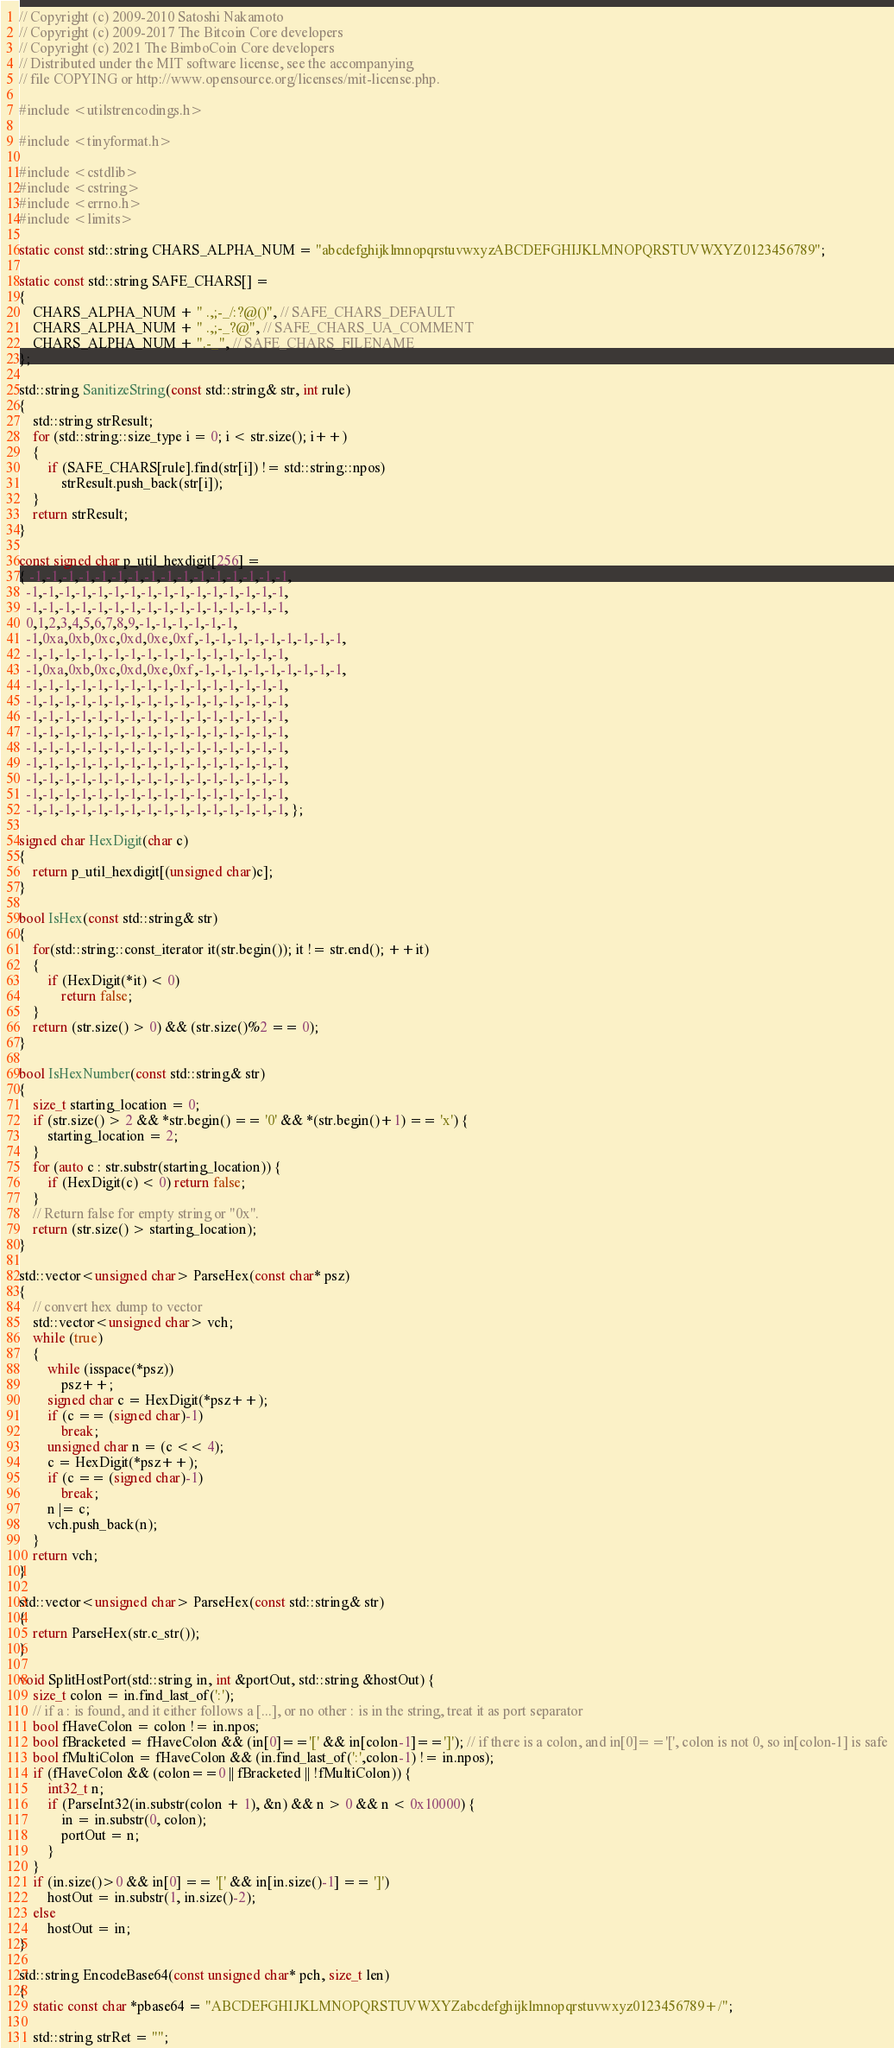Convert code to text. <code><loc_0><loc_0><loc_500><loc_500><_C++_>// Copyright (c) 2009-2010 Satoshi Nakamoto
// Copyright (c) 2009-2017 The Bitcoin Core developers
// Copyright (c) 2021 The BimboCoin Core developers
// Distributed under the MIT software license, see the accompanying
// file COPYING or http://www.opensource.org/licenses/mit-license.php.

#include <utilstrencodings.h>

#include <tinyformat.h>

#include <cstdlib>
#include <cstring>
#include <errno.h>
#include <limits>

static const std::string CHARS_ALPHA_NUM = "abcdefghijklmnopqrstuvwxyzABCDEFGHIJKLMNOPQRSTUVWXYZ0123456789";

static const std::string SAFE_CHARS[] =
{
    CHARS_ALPHA_NUM + " .,;-_/:?@()", // SAFE_CHARS_DEFAULT
    CHARS_ALPHA_NUM + " .,;-_?@", // SAFE_CHARS_UA_COMMENT
    CHARS_ALPHA_NUM + ".-_", // SAFE_CHARS_FILENAME
};

std::string SanitizeString(const std::string& str, int rule)
{
    std::string strResult;
    for (std::string::size_type i = 0; i < str.size(); i++)
    {
        if (SAFE_CHARS[rule].find(str[i]) != std::string::npos)
            strResult.push_back(str[i]);
    }
    return strResult;
}

const signed char p_util_hexdigit[256] =
{ -1,-1,-1,-1,-1,-1,-1,-1,-1,-1,-1,-1,-1,-1,-1,-1,
  -1,-1,-1,-1,-1,-1,-1,-1,-1,-1,-1,-1,-1,-1,-1,-1,
  -1,-1,-1,-1,-1,-1,-1,-1,-1,-1,-1,-1,-1,-1,-1,-1,
  0,1,2,3,4,5,6,7,8,9,-1,-1,-1,-1,-1,-1,
  -1,0xa,0xb,0xc,0xd,0xe,0xf,-1,-1,-1,-1,-1,-1,-1,-1,-1,
  -1,-1,-1,-1,-1,-1,-1,-1,-1,-1,-1,-1,-1,-1,-1,-1,
  -1,0xa,0xb,0xc,0xd,0xe,0xf,-1,-1,-1,-1,-1,-1,-1,-1,-1,
  -1,-1,-1,-1,-1,-1,-1,-1,-1,-1,-1,-1,-1,-1,-1,-1,
  -1,-1,-1,-1,-1,-1,-1,-1,-1,-1,-1,-1,-1,-1,-1,-1,
  -1,-1,-1,-1,-1,-1,-1,-1,-1,-1,-1,-1,-1,-1,-1,-1,
  -1,-1,-1,-1,-1,-1,-1,-1,-1,-1,-1,-1,-1,-1,-1,-1,
  -1,-1,-1,-1,-1,-1,-1,-1,-1,-1,-1,-1,-1,-1,-1,-1,
  -1,-1,-1,-1,-1,-1,-1,-1,-1,-1,-1,-1,-1,-1,-1,-1,
  -1,-1,-1,-1,-1,-1,-1,-1,-1,-1,-1,-1,-1,-1,-1,-1,
  -1,-1,-1,-1,-1,-1,-1,-1,-1,-1,-1,-1,-1,-1,-1,-1,
  -1,-1,-1,-1,-1,-1,-1,-1,-1,-1,-1,-1,-1,-1,-1,-1, };

signed char HexDigit(char c)
{
    return p_util_hexdigit[(unsigned char)c];
}

bool IsHex(const std::string& str)
{
    for(std::string::const_iterator it(str.begin()); it != str.end(); ++it)
    {
        if (HexDigit(*it) < 0)
            return false;
    }
    return (str.size() > 0) && (str.size()%2 == 0);
}

bool IsHexNumber(const std::string& str)
{
    size_t starting_location = 0;
    if (str.size() > 2 && *str.begin() == '0' && *(str.begin()+1) == 'x') {
        starting_location = 2;
    }
    for (auto c : str.substr(starting_location)) {
        if (HexDigit(c) < 0) return false;
    }
    // Return false for empty string or "0x".
    return (str.size() > starting_location);
}

std::vector<unsigned char> ParseHex(const char* psz)
{
    // convert hex dump to vector
    std::vector<unsigned char> vch;
    while (true)
    {
        while (isspace(*psz))
            psz++;
        signed char c = HexDigit(*psz++);
        if (c == (signed char)-1)
            break;
        unsigned char n = (c << 4);
        c = HexDigit(*psz++);
        if (c == (signed char)-1)
            break;
        n |= c;
        vch.push_back(n);
    }
    return vch;
}

std::vector<unsigned char> ParseHex(const std::string& str)
{
    return ParseHex(str.c_str());
}

void SplitHostPort(std::string in, int &portOut, std::string &hostOut) {
    size_t colon = in.find_last_of(':');
    // if a : is found, and it either follows a [...], or no other : is in the string, treat it as port separator
    bool fHaveColon = colon != in.npos;
    bool fBracketed = fHaveColon && (in[0]=='[' && in[colon-1]==']'); // if there is a colon, and in[0]=='[', colon is not 0, so in[colon-1] is safe
    bool fMultiColon = fHaveColon && (in.find_last_of(':',colon-1) != in.npos);
    if (fHaveColon && (colon==0 || fBracketed || !fMultiColon)) {
        int32_t n;
        if (ParseInt32(in.substr(colon + 1), &n) && n > 0 && n < 0x10000) {
            in = in.substr(0, colon);
            portOut = n;
        }
    }
    if (in.size()>0 && in[0] == '[' && in[in.size()-1] == ']')
        hostOut = in.substr(1, in.size()-2);
    else
        hostOut = in;
}

std::string EncodeBase64(const unsigned char* pch, size_t len)
{
    static const char *pbase64 = "ABCDEFGHIJKLMNOPQRSTUVWXYZabcdefghijklmnopqrstuvwxyz0123456789+/";

    std::string strRet = "";</code> 